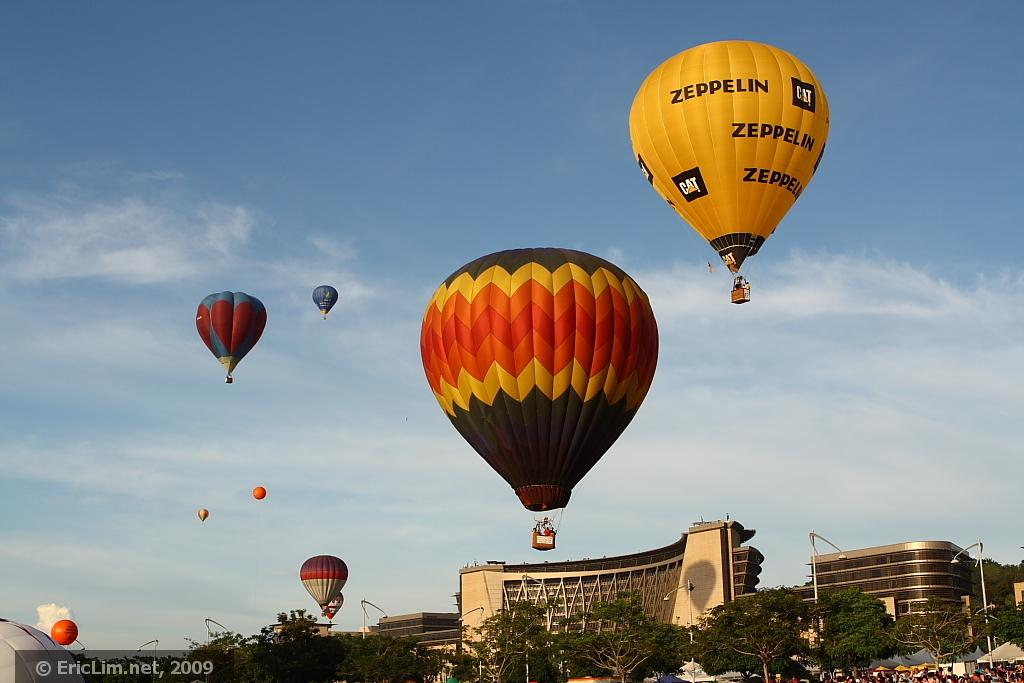<image>
Share a concise interpretation of the image provided. A hot air balloon with the label Zeppelin soars above several others beginning to take off. 